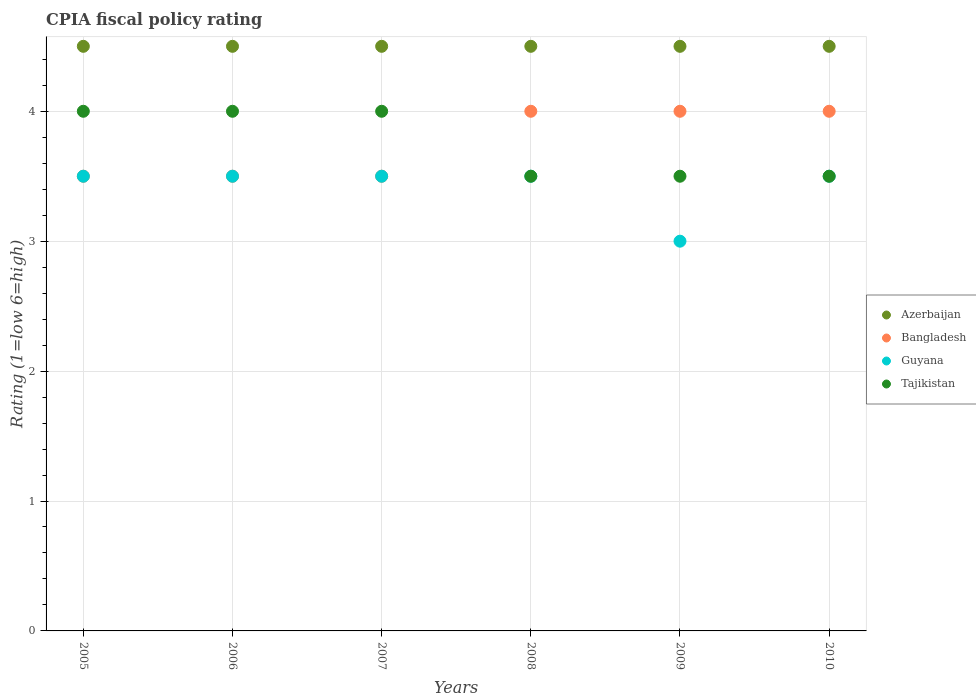How many different coloured dotlines are there?
Ensure brevity in your answer.  4. Is the number of dotlines equal to the number of legend labels?
Make the answer very short. Yes. What is the CPIA rating in Azerbaijan in 2010?
Keep it short and to the point. 4.5. Across all years, what is the minimum CPIA rating in Bangladesh?
Your response must be concise. 3.5. In which year was the CPIA rating in Tajikistan maximum?
Make the answer very short. 2005. In which year was the CPIA rating in Bangladesh minimum?
Ensure brevity in your answer.  2005. What is the total CPIA rating in Azerbaijan in the graph?
Offer a terse response. 27. What is the difference between the CPIA rating in Azerbaijan in 2005 and that in 2007?
Your answer should be very brief. 0. What is the difference between the CPIA rating in Guyana in 2006 and the CPIA rating in Tajikistan in 2005?
Your answer should be very brief. -0.5. What is the average CPIA rating in Tajikistan per year?
Make the answer very short. 3.75. In the year 2009, what is the difference between the CPIA rating in Bangladesh and CPIA rating in Azerbaijan?
Provide a succinct answer. -0.5. In how many years, is the CPIA rating in Tajikistan greater than 1.4?
Keep it short and to the point. 6. What is the difference between the highest and the lowest CPIA rating in Azerbaijan?
Make the answer very short. 0. In how many years, is the CPIA rating in Guyana greater than the average CPIA rating in Guyana taken over all years?
Your answer should be very brief. 5. Is the sum of the CPIA rating in Bangladesh in 2007 and 2010 greater than the maximum CPIA rating in Tajikistan across all years?
Give a very brief answer. Yes. Is it the case that in every year, the sum of the CPIA rating in Azerbaijan and CPIA rating in Guyana  is greater than the sum of CPIA rating in Bangladesh and CPIA rating in Tajikistan?
Make the answer very short. No. Does the CPIA rating in Tajikistan monotonically increase over the years?
Your response must be concise. No. How many years are there in the graph?
Ensure brevity in your answer.  6. Does the graph contain any zero values?
Your answer should be compact. No. Does the graph contain grids?
Your answer should be very brief. Yes. How are the legend labels stacked?
Make the answer very short. Vertical. What is the title of the graph?
Give a very brief answer. CPIA fiscal policy rating. Does "Kosovo" appear as one of the legend labels in the graph?
Your answer should be very brief. No. What is the label or title of the X-axis?
Give a very brief answer. Years. What is the Rating (1=low 6=high) of Bangladesh in 2005?
Make the answer very short. 3.5. What is the Rating (1=low 6=high) of Guyana in 2005?
Ensure brevity in your answer.  3.5. What is the Rating (1=low 6=high) of Bangladesh in 2006?
Your response must be concise. 3.5. What is the Rating (1=low 6=high) of Guyana in 2006?
Offer a very short reply. 3.5. What is the Rating (1=low 6=high) in Azerbaijan in 2007?
Offer a very short reply. 4.5. What is the Rating (1=low 6=high) of Tajikistan in 2007?
Your answer should be compact. 4. What is the Rating (1=low 6=high) of Guyana in 2008?
Give a very brief answer. 3.5. What is the Rating (1=low 6=high) in Tajikistan in 2008?
Provide a succinct answer. 3.5. What is the Rating (1=low 6=high) in Bangladesh in 2009?
Offer a very short reply. 4. What is the Rating (1=low 6=high) of Guyana in 2009?
Give a very brief answer. 3. What is the Rating (1=low 6=high) of Tajikistan in 2009?
Your response must be concise. 3.5. What is the Rating (1=low 6=high) in Azerbaijan in 2010?
Your answer should be very brief. 4.5. What is the Rating (1=low 6=high) of Bangladesh in 2010?
Give a very brief answer. 4. What is the Rating (1=low 6=high) of Guyana in 2010?
Offer a very short reply. 3.5. What is the Rating (1=low 6=high) of Tajikistan in 2010?
Make the answer very short. 3.5. Across all years, what is the maximum Rating (1=low 6=high) of Bangladesh?
Give a very brief answer. 4. Across all years, what is the maximum Rating (1=low 6=high) in Guyana?
Offer a terse response. 3.5. Across all years, what is the maximum Rating (1=low 6=high) in Tajikistan?
Provide a short and direct response. 4. Across all years, what is the minimum Rating (1=low 6=high) in Bangladesh?
Give a very brief answer. 3.5. Across all years, what is the minimum Rating (1=low 6=high) in Guyana?
Make the answer very short. 3. Across all years, what is the minimum Rating (1=low 6=high) in Tajikistan?
Provide a short and direct response. 3.5. What is the total Rating (1=low 6=high) in Bangladesh in the graph?
Your answer should be very brief. 22.5. What is the total Rating (1=low 6=high) of Guyana in the graph?
Offer a terse response. 20.5. What is the total Rating (1=low 6=high) in Tajikistan in the graph?
Provide a succinct answer. 22.5. What is the difference between the Rating (1=low 6=high) in Tajikistan in 2005 and that in 2006?
Provide a short and direct response. 0. What is the difference between the Rating (1=low 6=high) in Azerbaijan in 2005 and that in 2007?
Provide a succinct answer. 0. What is the difference between the Rating (1=low 6=high) in Guyana in 2005 and that in 2007?
Keep it short and to the point. 0. What is the difference between the Rating (1=low 6=high) in Tajikistan in 2005 and that in 2007?
Make the answer very short. 0. What is the difference between the Rating (1=low 6=high) in Azerbaijan in 2005 and that in 2009?
Offer a terse response. 0. What is the difference between the Rating (1=low 6=high) of Guyana in 2005 and that in 2009?
Your answer should be very brief. 0.5. What is the difference between the Rating (1=low 6=high) in Guyana in 2005 and that in 2010?
Your answer should be very brief. 0. What is the difference between the Rating (1=low 6=high) in Tajikistan in 2005 and that in 2010?
Offer a terse response. 0.5. What is the difference between the Rating (1=low 6=high) of Azerbaijan in 2006 and that in 2007?
Your answer should be compact. 0. What is the difference between the Rating (1=low 6=high) of Bangladesh in 2006 and that in 2007?
Your answer should be very brief. 0. What is the difference between the Rating (1=low 6=high) in Guyana in 2006 and that in 2007?
Keep it short and to the point. 0. What is the difference between the Rating (1=low 6=high) in Tajikistan in 2006 and that in 2007?
Provide a short and direct response. 0. What is the difference between the Rating (1=low 6=high) of Azerbaijan in 2006 and that in 2008?
Your response must be concise. 0. What is the difference between the Rating (1=low 6=high) of Azerbaijan in 2006 and that in 2009?
Make the answer very short. 0. What is the difference between the Rating (1=low 6=high) in Bangladesh in 2006 and that in 2009?
Offer a terse response. -0.5. What is the difference between the Rating (1=low 6=high) in Tajikistan in 2006 and that in 2010?
Make the answer very short. 0.5. What is the difference between the Rating (1=low 6=high) of Azerbaijan in 2007 and that in 2009?
Your answer should be compact. 0. What is the difference between the Rating (1=low 6=high) of Guyana in 2007 and that in 2009?
Provide a short and direct response. 0.5. What is the difference between the Rating (1=low 6=high) in Azerbaijan in 2007 and that in 2010?
Ensure brevity in your answer.  0. What is the difference between the Rating (1=low 6=high) of Bangladesh in 2007 and that in 2010?
Offer a very short reply. -0.5. What is the difference between the Rating (1=low 6=high) in Tajikistan in 2008 and that in 2009?
Offer a terse response. 0. What is the difference between the Rating (1=low 6=high) of Bangladesh in 2008 and that in 2010?
Make the answer very short. 0. What is the difference between the Rating (1=low 6=high) in Bangladesh in 2009 and that in 2010?
Your response must be concise. 0. What is the difference between the Rating (1=low 6=high) in Guyana in 2009 and that in 2010?
Offer a terse response. -0.5. What is the difference between the Rating (1=low 6=high) in Tajikistan in 2009 and that in 2010?
Your response must be concise. 0. What is the difference between the Rating (1=low 6=high) of Azerbaijan in 2005 and the Rating (1=low 6=high) of Bangladesh in 2006?
Your response must be concise. 1. What is the difference between the Rating (1=low 6=high) of Azerbaijan in 2005 and the Rating (1=low 6=high) of Guyana in 2006?
Keep it short and to the point. 1. What is the difference between the Rating (1=low 6=high) in Azerbaijan in 2005 and the Rating (1=low 6=high) in Tajikistan in 2006?
Offer a terse response. 0.5. What is the difference between the Rating (1=low 6=high) in Bangladesh in 2005 and the Rating (1=low 6=high) in Guyana in 2006?
Offer a terse response. 0. What is the difference between the Rating (1=low 6=high) of Bangladesh in 2005 and the Rating (1=low 6=high) of Tajikistan in 2007?
Your answer should be compact. -0.5. What is the difference between the Rating (1=low 6=high) of Guyana in 2005 and the Rating (1=low 6=high) of Tajikistan in 2007?
Your answer should be very brief. -0.5. What is the difference between the Rating (1=low 6=high) in Azerbaijan in 2005 and the Rating (1=low 6=high) in Bangladesh in 2008?
Keep it short and to the point. 0.5. What is the difference between the Rating (1=low 6=high) of Azerbaijan in 2005 and the Rating (1=low 6=high) of Guyana in 2008?
Give a very brief answer. 1. What is the difference between the Rating (1=low 6=high) in Azerbaijan in 2005 and the Rating (1=low 6=high) in Tajikistan in 2008?
Provide a succinct answer. 1. What is the difference between the Rating (1=low 6=high) in Bangladesh in 2005 and the Rating (1=low 6=high) in Tajikistan in 2008?
Keep it short and to the point. 0. What is the difference between the Rating (1=low 6=high) in Guyana in 2005 and the Rating (1=low 6=high) in Tajikistan in 2008?
Offer a very short reply. 0. What is the difference between the Rating (1=low 6=high) of Bangladesh in 2005 and the Rating (1=low 6=high) of Tajikistan in 2009?
Your response must be concise. 0. What is the difference between the Rating (1=low 6=high) in Guyana in 2005 and the Rating (1=low 6=high) in Tajikistan in 2009?
Your answer should be compact. 0. What is the difference between the Rating (1=low 6=high) in Azerbaijan in 2005 and the Rating (1=low 6=high) in Guyana in 2010?
Your answer should be very brief. 1. What is the difference between the Rating (1=low 6=high) of Bangladesh in 2005 and the Rating (1=low 6=high) of Guyana in 2010?
Your answer should be very brief. 0. What is the difference between the Rating (1=low 6=high) in Azerbaijan in 2006 and the Rating (1=low 6=high) in Bangladesh in 2007?
Offer a very short reply. 1. What is the difference between the Rating (1=low 6=high) of Bangladesh in 2006 and the Rating (1=low 6=high) of Guyana in 2007?
Provide a succinct answer. 0. What is the difference between the Rating (1=low 6=high) in Azerbaijan in 2006 and the Rating (1=low 6=high) in Bangladesh in 2008?
Keep it short and to the point. 0.5. What is the difference between the Rating (1=low 6=high) in Bangladesh in 2006 and the Rating (1=low 6=high) in Guyana in 2008?
Offer a very short reply. 0. What is the difference between the Rating (1=low 6=high) of Bangladesh in 2006 and the Rating (1=low 6=high) of Tajikistan in 2008?
Offer a terse response. 0. What is the difference between the Rating (1=low 6=high) in Guyana in 2006 and the Rating (1=low 6=high) in Tajikistan in 2008?
Ensure brevity in your answer.  0. What is the difference between the Rating (1=low 6=high) in Azerbaijan in 2006 and the Rating (1=low 6=high) in Bangladesh in 2009?
Ensure brevity in your answer.  0.5. What is the difference between the Rating (1=low 6=high) of Azerbaijan in 2006 and the Rating (1=low 6=high) of Tajikistan in 2009?
Offer a terse response. 1. What is the difference between the Rating (1=low 6=high) of Bangladesh in 2006 and the Rating (1=low 6=high) of Guyana in 2009?
Make the answer very short. 0.5. What is the difference between the Rating (1=low 6=high) in Azerbaijan in 2006 and the Rating (1=low 6=high) in Bangladesh in 2010?
Your answer should be very brief. 0.5. What is the difference between the Rating (1=low 6=high) of Azerbaijan in 2006 and the Rating (1=low 6=high) of Guyana in 2010?
Offer a terse response. 1. What is the difference between the Rating (1=low 6=high) of Azerbaijan in 2006 and the Rating (1=low 6=high) of Tajikistan in 2010?
Provide a short and direct response. 1. What is the difference between the Rating (1=low 6=high) in Bangladesh in 2006 and the Rating (1=low 6=high) in Guyana in 2010?
Offer a terse response. 0. What is the difference between the Rating (1=low 6=high) in Guyana in 2006 and the Rating (1=low 6=high) in Tajikistan in 2010?
Offer a very short reply. 0. What is the difference between the Rating (1=low 6=high) in Azerbaijan in 2007 and the Rating (1=low 6=high) in Bangladesh in 2008?
Offer a terse response. 0.5. What is the difference between the Rating (1=low 6=high) of Azerbaijan in 2007 and the Rating (1=low 6=high) of Tajikistan in 2008?
Provide a succinct answer. 1. What is the difference between the Rating (1=low 6=high) in Bangladesh in 2007 and the Rating (1=low 6=high) in Tajikistan in 2009?
Your answer should be very brief. 0. What is the difference between the Rating (1=low 6=high) of Guyana in 2007 and the Rating (1=low 6=high) of Tajikistan in 2009?
Your response must be concise. 0. What is the difference between the Rating (1=low 6=high) in Bangladesh in 2007 and the Rating (1=low 6=high) in Guyana in 2010?
Ensure brevity in your answer.  0. What is the difference between the Rating (1=low 6=high) of Guyana in 2007 and the Rating (1=low 6=high) of Tajikistan in 2010?
Ensure brevity in your answer.  0. What is the difference between the Rating (1=low 6=high) in Azerbaijan in 2008 and the Rating (1=low 6=high) in Guyana in 2009?
Make the answer very short. 1.5. What is the difference between the Rating (1=low 6=high) of Bangladesh in 2008 and the Rating (1=low 6=high) of Guyana in 2009?
Your answer should be very brief. 1. What is the difference between the Rating (1=low 6=high) of Azerbaijan in 2008 and the Rating (1=low 6=high) of Bangladesh in 2010?
Provide a succinct answer. 0.5. What is the difference between the Rating (1=low 6=high) in Azerbaijan in 2008 and the Rating (1=low 6=high) in Guyana in 2010?
Ensure brevity in your answer.  1. What is the difference between the Rating (1=low 6=high) of Azerbaijan in 2008 and the Rating (1=low 6=high) of Tajikistan in 2010?
Give a very brief answer. 1. What is the difference between the Rating (1=low 6=high) in Bangladesh in 2008 and the Rating (1=low 6=high) in Guyana in 2010?
Offer a very short reply. 0.5. What is the difference between the Rating (1=low 6=high) in Bangladesh in 2008 and the Rating (1=low 6=high) in Tajikistan in 2010?
Keep it short and to the point. 0.5. What is the difference between the Rating (1=low 6=high) in Guyana in 2008 and the Rating (1=low 6=high) in Tajikistan in 2010?
Keep it short and to the point. 0. What is the difference between the Rating (1=low 6=high) in Azerbaijan in 2009 and the Rating (1=low 6=high) in Guyana in 2010?
Provide a succinct answer. 1. What is the difference between the Rating (1=low 6=high) in Bangladesh in 2009 and the Rating (1=low 6=high) in Guyana in 2010?
Make the answer very short. 0.5. What is the difference between the Rating (1=low 6=high) in Bangladesh in 2009 and the Rating (1=low 6=high) in Tajikistan in 2010?
Provide a succinct answer. 0.5. What is the average Rating (1=low 6=high) in Azerbaijan per year?
Your response must be concise. 4.5. What is the average Rating (1=low 6=high) in Bangladesh per year?
Give a very brief answer. 3.75. What is the average Rating (1=low 6=high) of Guyana per year?
Keep it short and to the point. 3.42. What is the average Rating (1=low 6=high) of Tajikistan per year?
Your response must be concise. 3.75. In the year 2005, what is the difference between the Rating (1=low 6=high) in Azerbaijan and Rating (1=low 6=high) in Guyana?
Your answer should be very brief. 1. In the year 2005, what is the difference between the Rating (1=low 6=high) of Azerbaijan and Rating (1=low 6=high) of Tajikistan?
Provide a succinct answer. 0.5. In the year 2005, what is the difference between the Rating (1=low 6=high) in Guyana and Rating (1=low 6=high) in Tajikistan?
Make the answer very short. -0.5. In the year 2006, what is the difference between the Rating (1=low 6=high) in Azerbaijan and Rating (1=low 6=high) in Bangladesh?
Your answer should be very brief. 1. In the year 2006, what is the difference between the Rating (1=low 6=high) of Guyana and Rating (1=low 6=high) of Tajikistan?
Make the answer very short. -0.5. In the year 2007, what is the difference between the Rating (1=low 6=high) of Azerbaijan and Rating (1=low 6=high) of Guyana?
Ensure brevity in your answer.  1. In the year 2007, what is the difference between the Rating (1=low 6=high) in Azerbaijan and Rating (1=low 6=high) in Tajikistan?
Offer a very short reply. 0.5. In the year 2007, what is the difference between the Rating (1=low 6=high) in Bangladesh and Rating (1=low 6=high) in Tajikistan?
Your answer should be compact. -0.5. In the year 2008, what is the difference between the Rating (1=low 6=high) in Azerbaijan and Rating (1=low 6=high) in Tajikistan?
Your answer should be very brief. 1. In the year 2008, what is the difference between the Rating (1=low 6=high) of Bangladesh and Rating (1=low 6=high) of Guyana?
Your answer should be compact. 0.5. In the year 2009, what is the difference between the Rating (1=low 6=high) in Azerbaijan and Rating (1=low 6=high) in Bangladesh?
Offer a very short reply. 0.5. In the year 2009, what is the difference between the Rating (1=low 6=high) of Azerbaijan and Rating (1=low 6=high) of Guyana?
Provide a short and direct response. 1.5. In the year 2009, what is the difference between the Rating (1=low 6=high) in Azerbaijan and Rating (1=low 6=high) in Tajikistan?
Give a very brief answer. 1. In the year 2010, what is the difference between the Rating (1=low 6=high) in Azerbaijan and Rating (1=low 6=high) in Tajikistan?
Keep it short and to the point. 1. In the year 2010, what is the difference between the Rating (1=low 6=high) in Bangladesh and Rating (1=low 6=high) in Guyana?
Your response must be concise. 0.5. What is the ratio of the Rating (1=low 6=high) of Azerbaijan in 2005 to that in 2006?
Ensure brevity in your answer.  1. What is the ratio of the Rating (1=low 6=high) of Guyana in 2005 to that in 2006?
Keep it short and to the point. 1. What is the ratio of the Rating (1=low 6=high) of Tajikistan in 2005 to that in 2006?
Make the answer very short. 1. What is the ratio of the Rating (1=low 6=high) of Bangladesh in 2005 to that in 2007?
Give a very brief answer. 1. What is the ratio of the Rating (1=low 6=high) of Guyana in 2005 to that in 2007?
Provide a short and direct response. 1. What is the ratio of the Rating (1=low 6=high) in Tajikistan in 2005 to that in 2007?
Ensure brevity in your answer.  1. What is the ratio of the Rating (1=low 6=high) in Azerbaijan in 2005 to that in 2008?
Provide a short and direct response. 1. What is the ratio of the Rating (1=low 6=high) in Tajikistan in 2005 to that in 2008?
Make the answer very short. 1.14. What is the ratio of the Rating (1=low 6=high) of Guyana in 2005 to that in 2009?
Ensure brevity in your answer.  1.17. What is the ratio of the Rating (1=low 6=high) in Tajikistan in 2005 to that in 2009?
Provide a succinct answer. 1.14. What is the ratio of the Rating (1=low 6=high) in Guyana in 2005 to that in 2010?
Offer a very short reply. 1. What is the ratio of the Rating (1=low 6=high) of Bangladesh in 2006 to that in 2007?
Your response must be concise. 1. What is the ratio of the Rating (1=low 6=high) of Bangladesh in 2006 to that in 2008?
Ensure brevity in your answer.  0.88. What is the ratio of the Rating (1=low 6=high) in Guyana in 2006 to that in 2008?
Make the answer very short. 1. What is the ratio of the Rating (1=low 6=high) in Azerbaijan in 2006 to that in 2009?
Provide a succinct answer. 1. What is the ratio of the Rating (1=low 6=high) in Bangladesh in 2006 to that in 2009?
Your answer should be compact. 0.88. What is the ratio of the Rating (1=low 6=high) of Guyana in 2006 to that in 2009?
Give a very brief answer. 1.17. What is the ratio of the Rating (1=low 6=high) in Tajikistan in 2006 to that in 2009?
Ensure brevity in your answer.  1.14. What is the ratio of the Rating (1=low 6=high) in Bangladesh in 2006 to that in 2010?
Provide a succinct answer. 0.88. What is the ratio of the Rating (1=low 6=high) of Tajikistan in 2007 to that in 2008?
Keep it short and to the point. 1.14. What is the ratio of the Rating (1=low 6=high) in Azerbaijan in 2007 to that in 2009?
Offer a very short reply. 1. What is the ratio of the Rating (1=low 6=high) in Bangladesh in 2007 to that in 2009?
Offer a terse response. 0.88. What is the ratio of the Rating (1=low 6=high) in Azerbaijan in 2007 to that in 2010?
Give a very brief answer. 1. What is the ratio of the Rating (1=low 6=high) in Guyana in 2007 to that in 2010?
Give a very brief answer. 1. What is the ratio of the Rating (1=low 6=high) of Bangladesh in 2008 to that in 2009?
Your answer should be compact. 1. What is the ratio of the Rating (1=low 6=high) in Guyana in 2008 to that in 2009?
Make the answer very short. 1.17. What is the ratio of the Rating (1=low 6=high) of Tajikistan in 2008 to that in 2009?
Keep it short and to the point. 1. What is the ratio of the Rating (1=low 6=high) in Bangladesh in 2008 to that in 2010?
Provide a succinct answer. 1. What is the ratio of the Rating (1=low 6=high) of Guyana in 2008 to that in 2010?
Make the answer very short. 1. What is the ratio of the Rating (1=low 6=high) in Azerbaijan in 2009 to that in 2010?
Make the answer very short. 1. What is the ratio of the Rating (1=low 6=high) in Bangladesh in 2009 to that in 2010?
Give a very brief answer. 1. What is the ratio of the Rating (1=low 6=high) of Guyana in 2009 to that in 2010?
Give a very brief answer. 0.86. What is the ratio of the Rating (1=low 6=high) of Tajikistan in 2009 to that in 2010?
Keep it short and to the point. 1. What is the difference between the highest and the second highest Rating (1=low 6=high) in Bangladesh?
Offer a terse response. 0. What is the difference between the highest and the second highest Rating (1=low 6=high) in Tajikistan?
Provide a short and direct response. 0. What is the difference between the highest and the lowest Rating (1=low 6=high) in Bangladesh?
Keep it short and to the point. 0.5. 